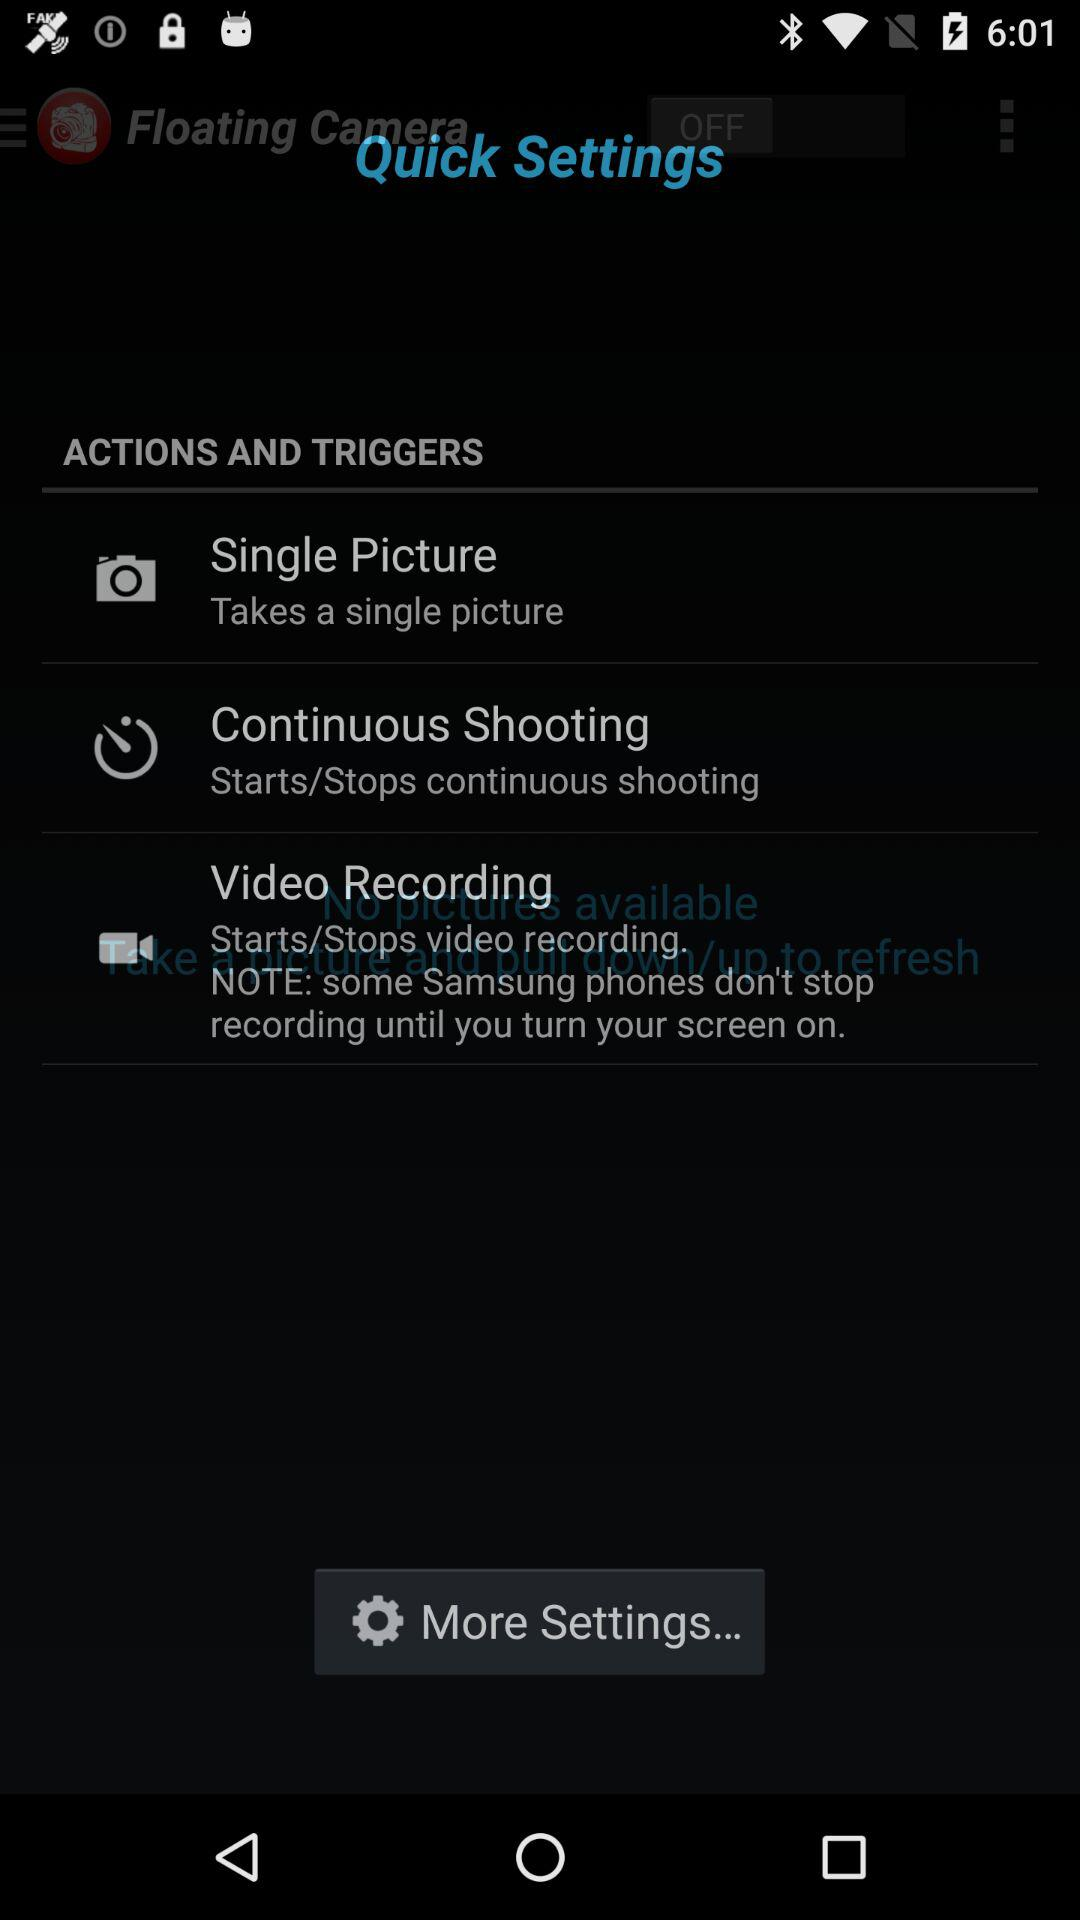How many actions and triggers are there?
Answer the question using a single word or phrase. 3 